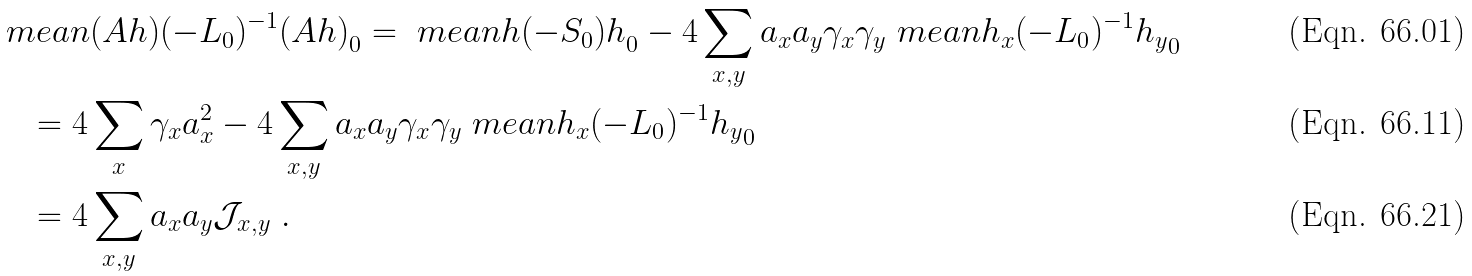<formula> <loc_0><loc_0><loc_500><loc_500>& \ m e a n { ( A h ) ( - L _ { 0 } ) ^ { - 1 } ( A h ) } _ { 0 } = \ m e a n { h ( - S _ { 0 } ) h } _ { 0 } - 4 \sum _ { x , y } a _ { x } a _ { y } \gamma _ { x } \gamma _ { y } \ m e a n { h _ { x } ( - L _ { 0 } ) ^ { - 1 } h _ { y } } _ { 0 } \\ & \quad = 4 \sum _ { x } \gamma _ { x } a _ { x } ^ { 2 } - 4 \sum _ { x , y } a _ { x } a _ { y } \gamma _ { x } \gamma _ { y } \ m e a n { h _ { x } ( - L _ { 0 } ) ^ { - 1 } h _ { y } } _ { 0 } \\ & \quad = 4 \sum _ { x , y } a _ { x } a _ { y } \mathcal { J } _ { x , y } \ .</formula> 